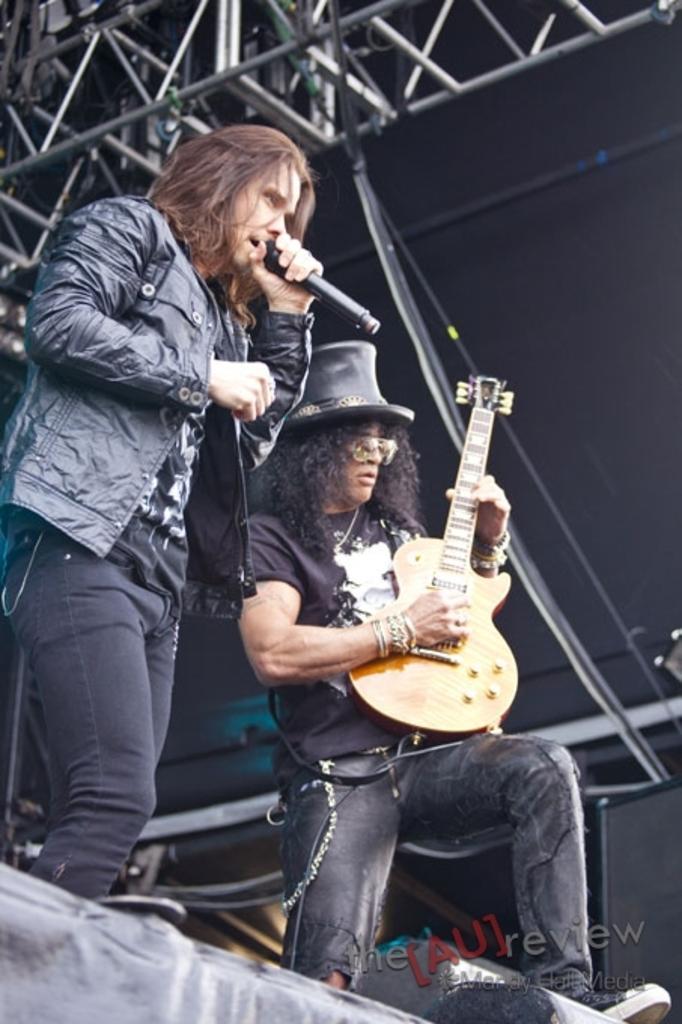In one or two sentences, can you explain what this image depicts? Image i can see two persons standing, the person here is singing by holding micro phone, the person here is playing a guitar. 